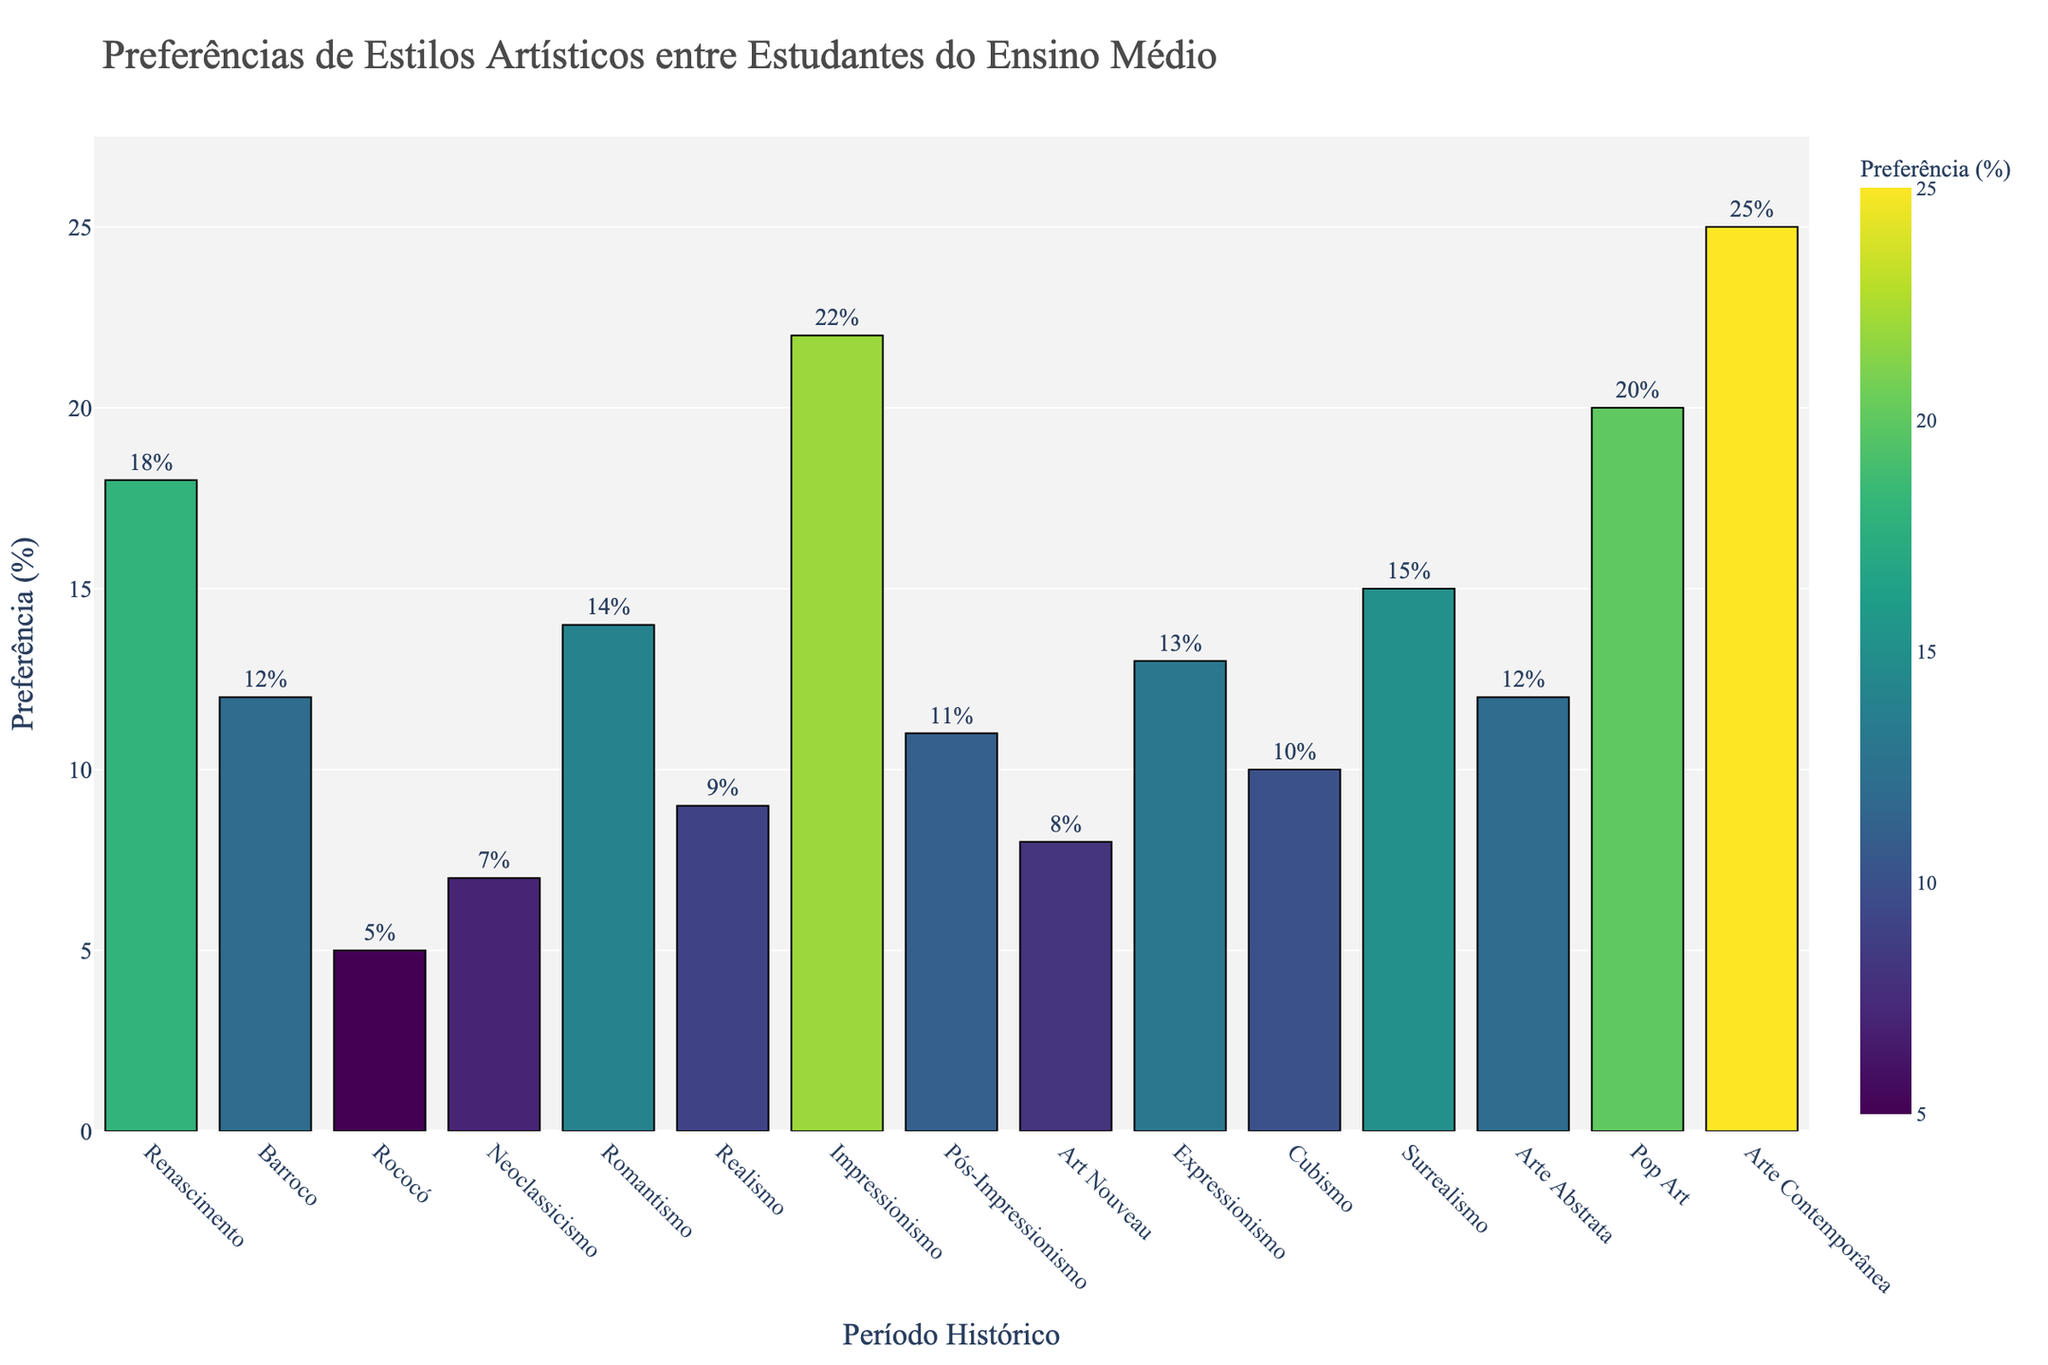What is the most preferred artistic style among high school students? The highest bar on the chart represents Arte Contemporânea with a preference percentage of 25%. By observing the heights of the bars and finding the tallest one, we identify the most preferred style.
Answer: Arte Contemporânea Which period has a higher preference, Romantismo or Realismo? The chart shows Romantismo with 14% and Realismo with 9%. By comparing the heights of these two bars, Romantismo has a higher preference.
Answer: Romantismo What is the sum of preferences for Impressionismo and Pop Art? Impressionismo has a preference of 22%, and Pop Art has 20%. Summing these values gives 22 + 20 = 42%.
Answer: 42% Which period has the lowest preference, and what is the percentage? The smallest bar on the chart represents Rococó with a preference of 5%. By identifying the shortest bar, we can determine the least preferred style.
Answer: Rococó with 5% What is the difference in preference between Barroco and Expressionismo? Barroco has a preference of 12% and Expressionismo has 13%. The difference is calculated as 13 - 12 = 1%.
Answer: 1% Does Arte Contemporânea have more than double the preference of Rococó? Arte Contemporânea has a preference of 25%, and Rococó has 5%. Doubling Rococó's preference gives 5 * 2 = 10%. Since 25% is more than 10%, Arte Contemporânea has more than double the preference of Rococó.
Answer: Yes What is the average preference percentage for the periods Renascimento, Barroco, and Rococó? Renascimento has 18%, Barroco has 12%, and Rococó has 5%. Summing these values gives 18 + 12 + 5 = 35%. Dividing by the number of periods (3), we get 35 / 3 ≈ 11.67%.
Answer: 11.67% Are there any periods with equal preference percentages? The chart shows that Barroco and Arte Abstrata both have a preference percentage of 12%. By comparing all the bars, we identify these two periods with equal values.
Answer: Yes, Barroco and Arte Abstrata What is the total preference percentage for modern art styles (Pop Art and Arte Contemporânea)? Pop Art has 20%, and Arte Contemporânea has 25%. Summing these values gives 20 + 25 = 45%.
Answer: 45% 